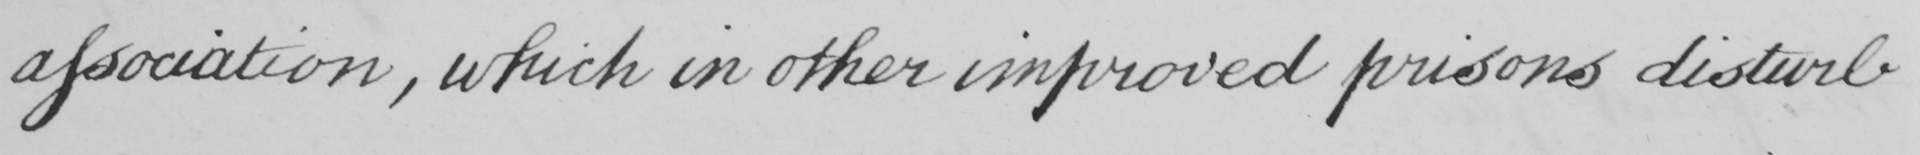Please provide the text content of this handwritten line. association, which in other improved prisons disturb 